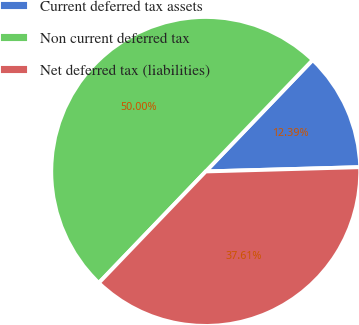Convert chart to OTSL. <chart><loc_0><loc_0><loc_500><loc_500><pie_chart><fcel>Current deferred tax assets<fcel>Non current deferred tax<fcel>Net deferred tax (liabilities)<nl><fcel>12.39%<fcel>50.0%<fcel>37.61%<nl></chart> 